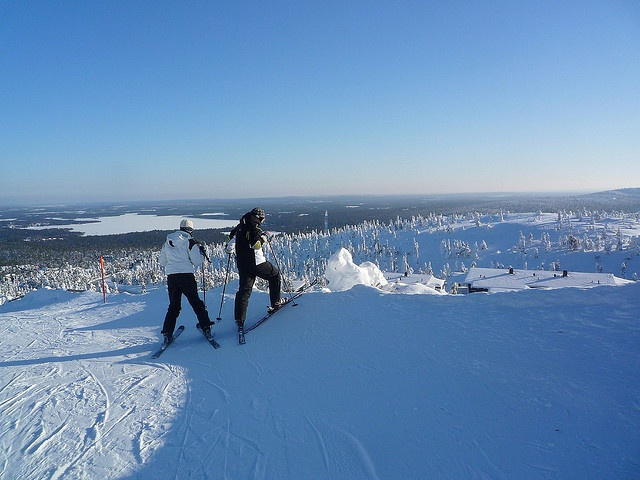Describe the objects in this image and their specific colors. I can see people in gray, black, lightgray, and darkgray tones, people in gray, black, and darkgray tones, skis in gray, black, navy, and blue tones, and skis in gray, navy, blue, and black tones in this image. 